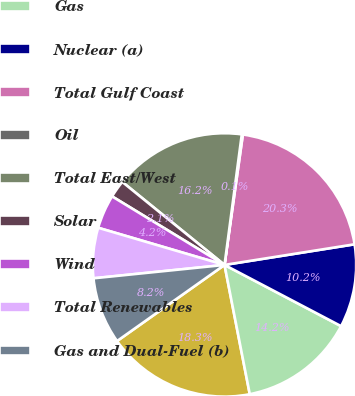<chart> <loc_0><loc_0><loc_500><loc_500><pie_chart><fcel>Coal<fcel>Gas<fcel>Nuclear (a)<fcel>Total Gulf Coast<fcel>Oil<fcel>Total East/West<fcel>Solar<fcel>Wind<fcel>Total Renewables<fcel>Gas and Dual-Fuel (b)<nl><fcel>18.26%<fcel>14.23%<fcel>10.2%<fcel>20.27%<fcel>0.13%<fcel>16.24%<fcel>2.14%<fcel>4.16%<fcel>6.17%<fcel>8.19%<nl></chart> 